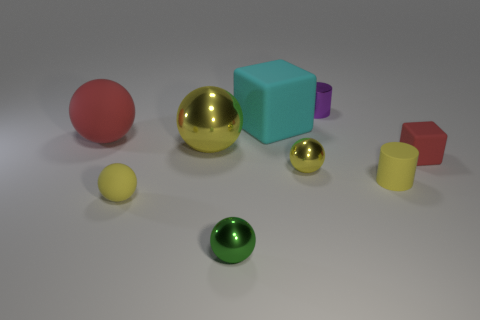There is a yellow shiny sphere to the right of the cyan matte cube; does it have the same size as the big yellow thing?
Your answer should be compact. No. What number of objects are either small purple matte spheres or tiny rubber objects?
Ensure brevity in your answer.  3. What is the shape of the tiny metal object that is the same color as the large shiny object?
Offer a very short reply. Sphere. There is a rubber thing that is both in front of the red matte cube and to the left of the green object; how big is it?
Offer a very short reply. Small. What number of small yellow rubber objects are there?
Offer a terse response. 2. What number of cylinders are tiny purple things or small metallic objects?
Provide a short and direct response. 1. There is a tiny yellow thing that is in front of the tiny cylinder that is in front of the large rubber sphere; what number of big balls are to the right of it?
Your response must be concise. 1. The shiny object that is the same size as the cyan rubber cube is what color?
Your answer should be very brief. Yellow. What number of other objects are the same color as the large shiny object?
Your answer should be compact. 3. Are there more small rubber spheres that are behind the big cyan rubber thing than small metal things?
Your answer should be very brief. No. 